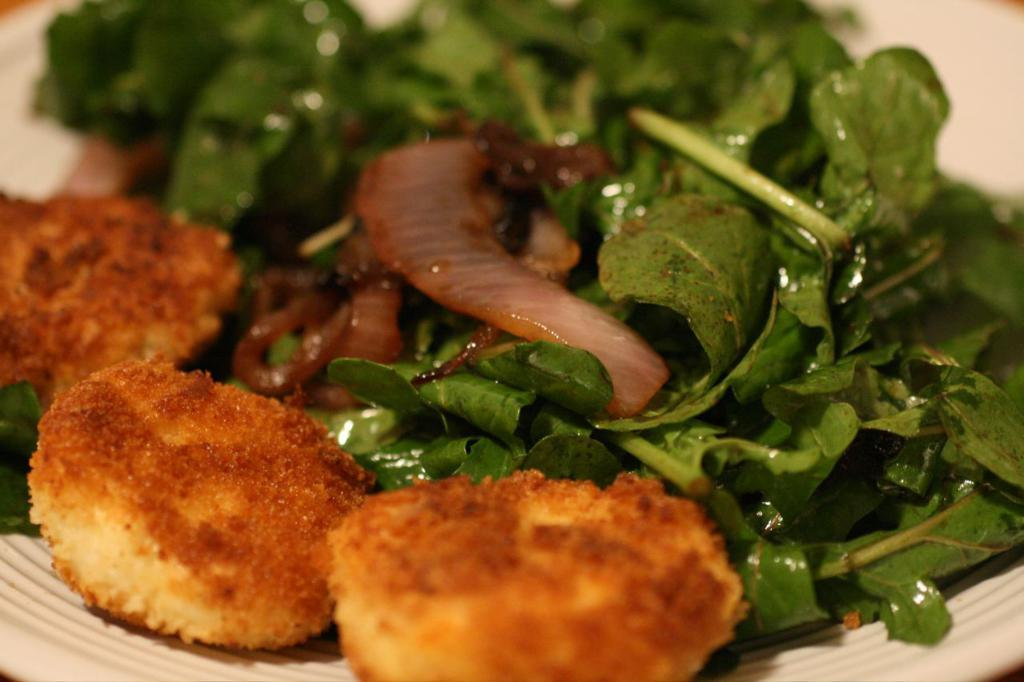What type of food is present on the white plate in the image? The facts provided do not specify the type of food on the white plate. What kind of vegetables can be seen in the image? There are leafy vegetables in the image. How many chairs are visible in the image? There are no chairs present in the image. What type of scale can be seen in the image? There is no scale present in the image. 